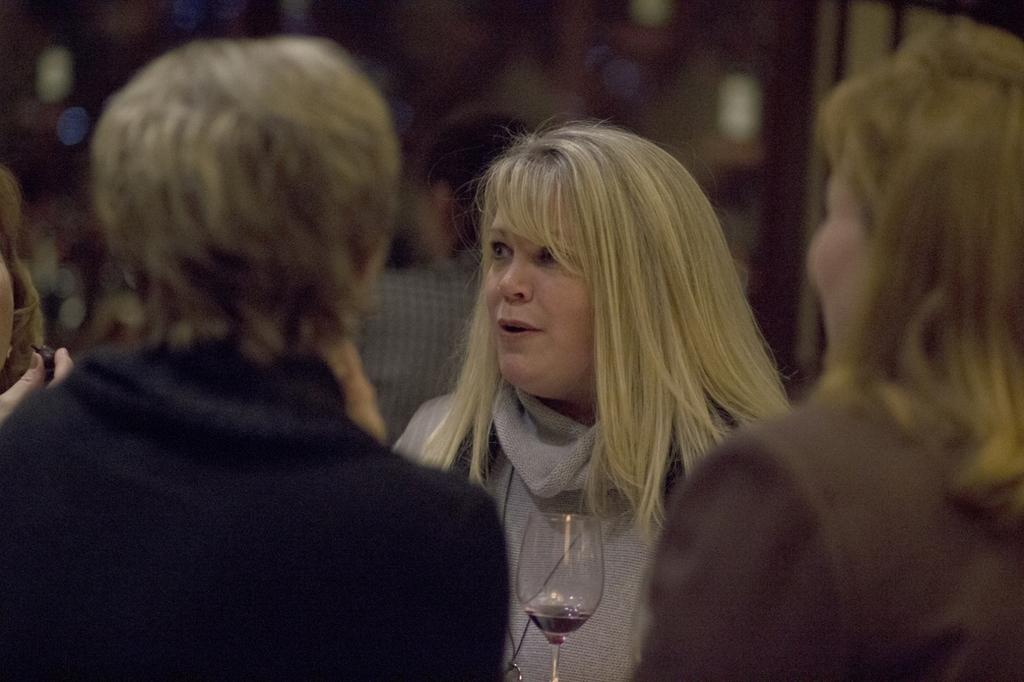What object is visible in the image? There is a glass in the image. Can you describe the people in the image? There are people in the image. What is the gender of the person mentioned in the facts? The person mentioned in the facts is a woman. How is the woman's expression in the image? The woman is smiling. What is the condition of the background in the image? The background of the image is blurry. What type of disease is affecting the deer on the hill in the image? There is no deer or hill present in the image, and therefore no disease can be observed. 